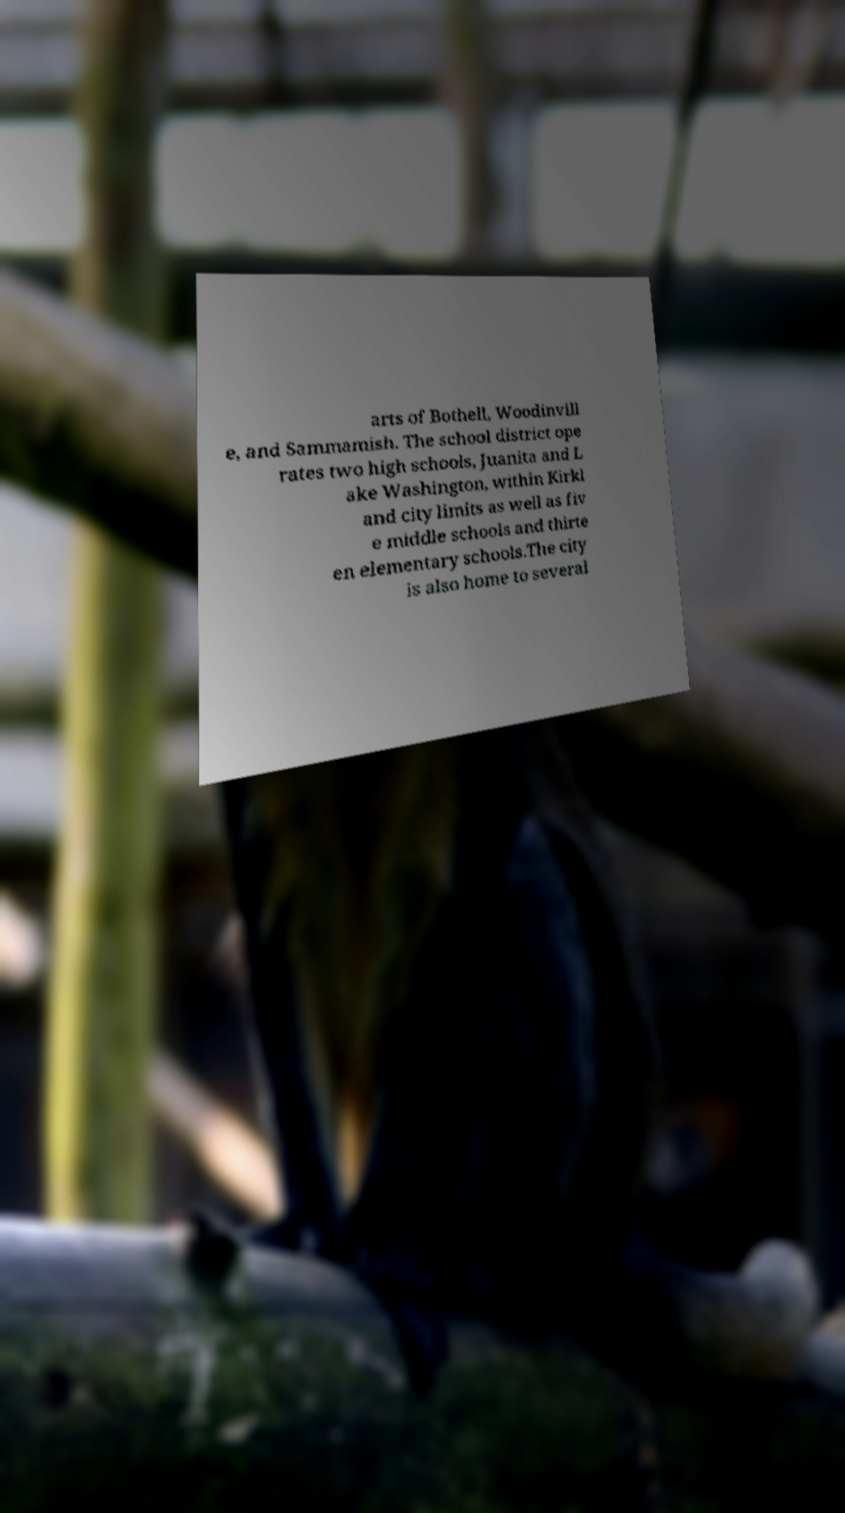Please identify and transcribe the text found in this image. arts of Bothell, Woodinvill e, and Sammamish. The school district ope rates two high schools, Juanita and L ake Washington, within Kirkl and city limits as well as fiv e middle schools and thirte en elementary schools.The city is also home to several 